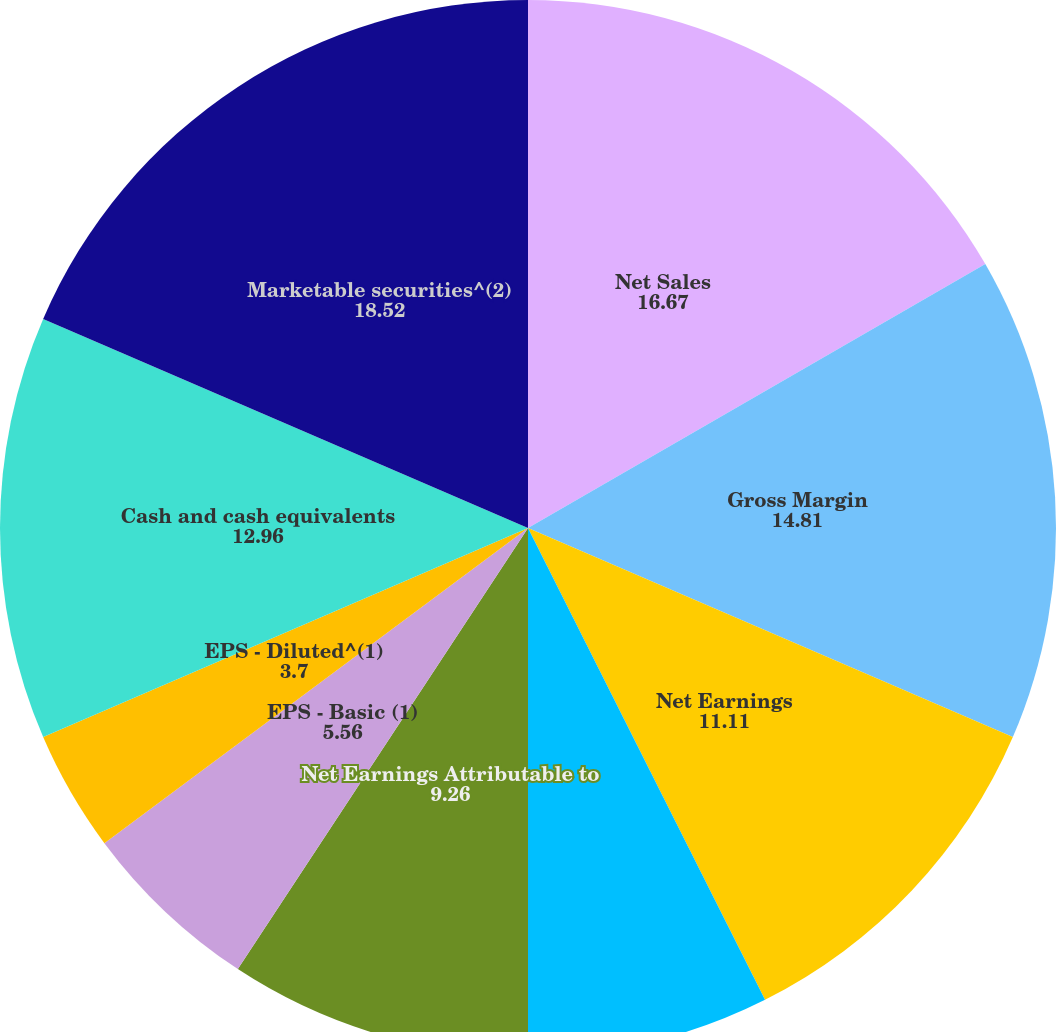Convert chart. <chart><loc_0><loc_0><loc_500><loc_500><pie_chart><fcel>Net Sales<fcel>Gross Margin<fcel>Net Earnings<fcel>Less Net Earnings Attributable<fcel>Net Earnings Attributable to<fcel>EPS - Basic (1)<fcel>EPS - Diluted^(1)<fcel>Dividends declared per common<fcel>Cash and cash equivalents<fcel>Marketable securities^(2)<nl><fcel>16.67%<fcel>14.81%<fcel>11.11%<fcel>7.41%<fcel>9.26%<fcel>5.56%<fcel>3.7%<fcel>0.0%<fcel>12.96%<fcel>18.52%<nl></chart> 